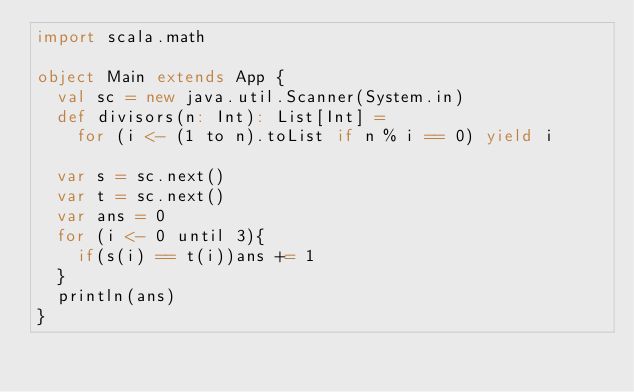<code> <loc_0><loc_0><loc_500><loc_500><_Scala_>import scala.math

object Main extends App {
  val sc = new java.util.Scanner(System.in)
  def divisors(n: Int): List[Int] =
    for (i <- (1 to n).toList if n % i == 0) yield i

  var s = sc.next()
  var t = sc.next()
  var ans = 0
  for (i <- 0 until 3){
    if(s(i) == t(i))ans += 1
  }
  println(ans)
}
</code> 